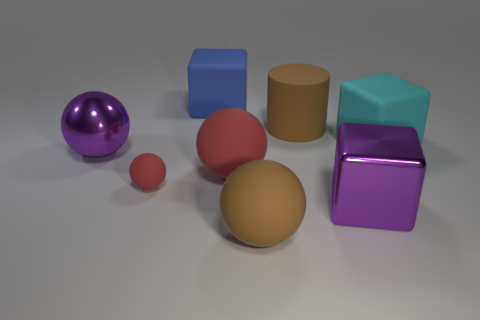Subtract all purple balls. How many balls are left? 3 Add 1 large brown cylinders. How many objects exist? 9 Subtract 0 gray spheres. How many objects are left? 8 Subtract all blocks. How many objects are left? 5 Subtract all purple objects. Subtract all matte things. How many objects are left? 0 Add 6 matte cylinders. How many matte cylinders are left? 7 Add 6 green metallic things. How many green metallic things exist? 6 